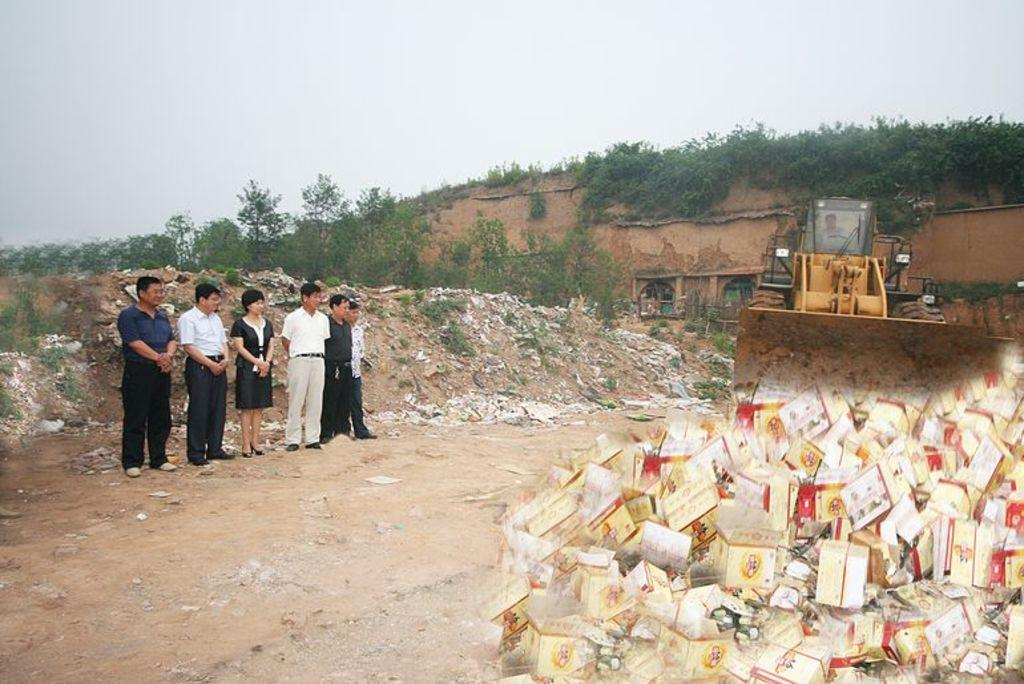What type of objects can be seen in the image? There are boxes in the image. What are the people in the image doing? There are people standing on the ground in the image. Can you describe the person in the vehicle? There is a person sitting in a vehicle in the image. What type of vegetation is present in the image? There are plants in the image. What other objects can be seen in the image besides the boxes? There are other objects in the image. What is visible in the background of the image? The sky is visible in the image. How many pins are being used to hold the boxes together in the image? There are no pins visible in the image; the boxes are not being held together with pins. What type of finger movements can be seen in the image? There is no specific finger movement depicted in the image. 